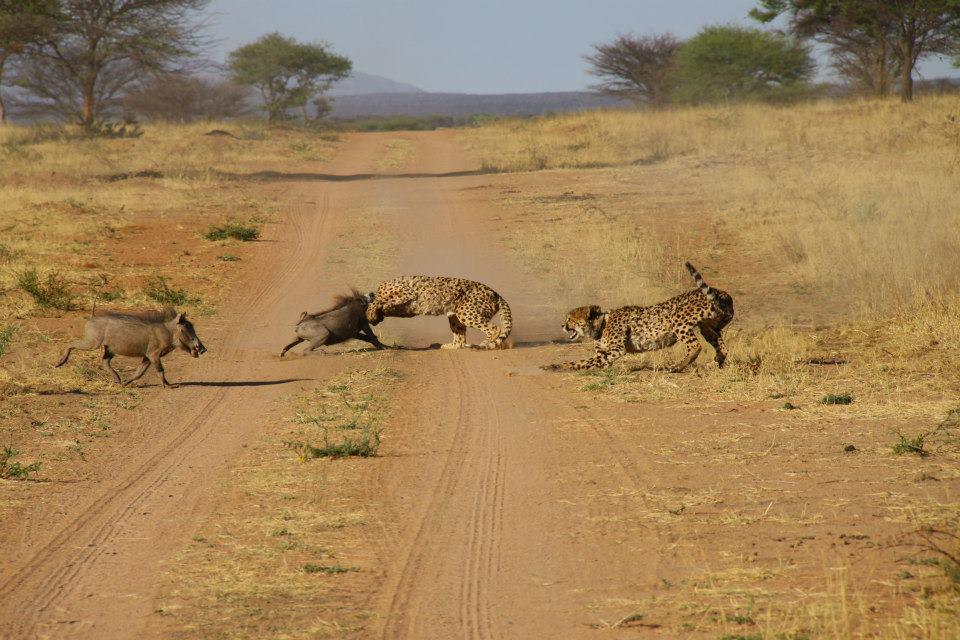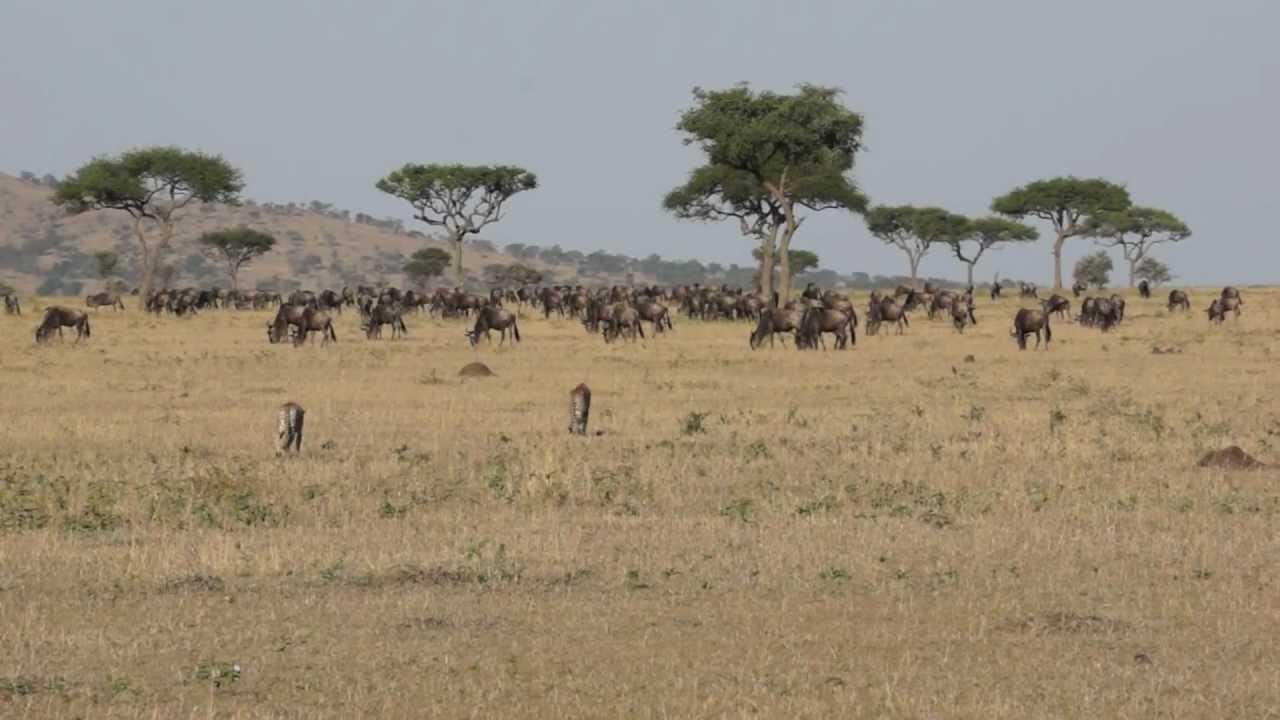The first image is the image on the left, the second image is the image on the right. Analyze the images presented: Is the assertion "Atleast one image contains 2 cheetahs fighting another animal" valid? Answer yes or no. Yes. The first image is the image on the left, the second image is the image on the right. Analyze the images presented: Is the assertion "At least one image shows only one cheetah." valid? Answer yes or no. No. 